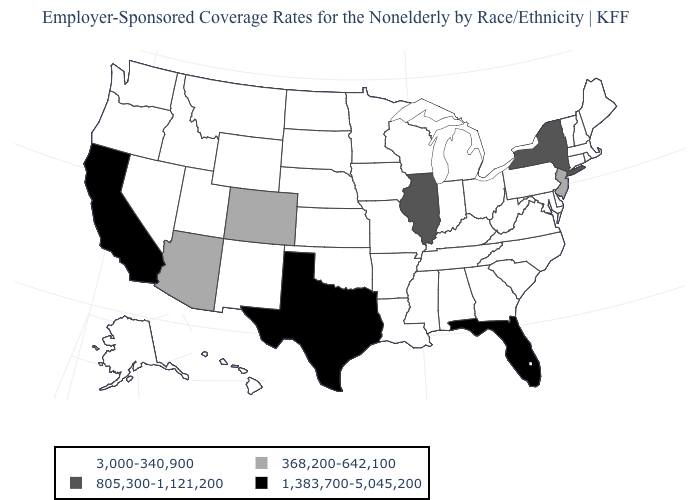Among the states that border Mississippi , which have the lowest value?
Give a very brief answer. Alabama, Arkansas, Louisiana, Tennessee. What is the value of New Jersey?
Give a very brief answer. 368,200-642,100. Name the states that have a value in the range 368,200-642,100?
Give a very brief answer. Arizona, Colorado, New Jersey. Among the states that border Minnesota , which have the lowest value?
Concise answer only. Iowa, North Dakota, South Dakota, Wisconsin. What is the value of North Carolina?
Answer briefly. 3,000-340,900. Does North Carolina have the same value as Texas?
Be succinct. No. Which states have the highest value in the USA?
Write a very short answer. California, Florida, Texas. What is the highest value in the MidWest ?
Keep it brief. 805,300-1,121,200. What is the highest value in the South ?
Short answer required. 1,383,700-5,045,200. What is the highest value in the USA?
Give a very brief answer. 1,383,700-5,045,200. Does the map have missing data?
Give a very brief answer. No. Name the states that have a value in the range 368,200-642,100?
Be succinct. Arizona, Colorado, New Jersey. What is the value of Massachusetts?
Write a very short answer. 3,000-340,900. Does Kentucky have the lowest value in the South?
Answer briefly. Yes. Does Maine have the highest value in the Northeast?
Short answer required. No. 